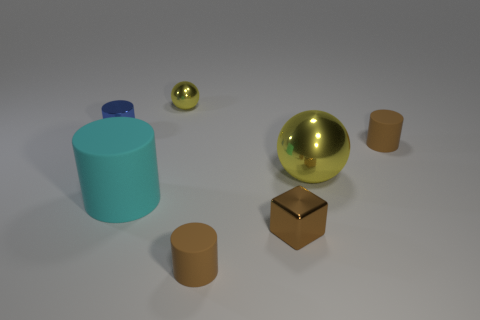Add 1 brown things. How many objects exist? 8 Subtract all spheres. How many objects are left? 5 Add 2 large balls. How many large balls are left? 3 Add 1 large spheres. How many large spheres exist? 2 Subtract 0 green spheres. How many objects are left? 7 Subtract all big cyan metal cylinders. Subtract all tiny cylinders. How many objects are left? 4 